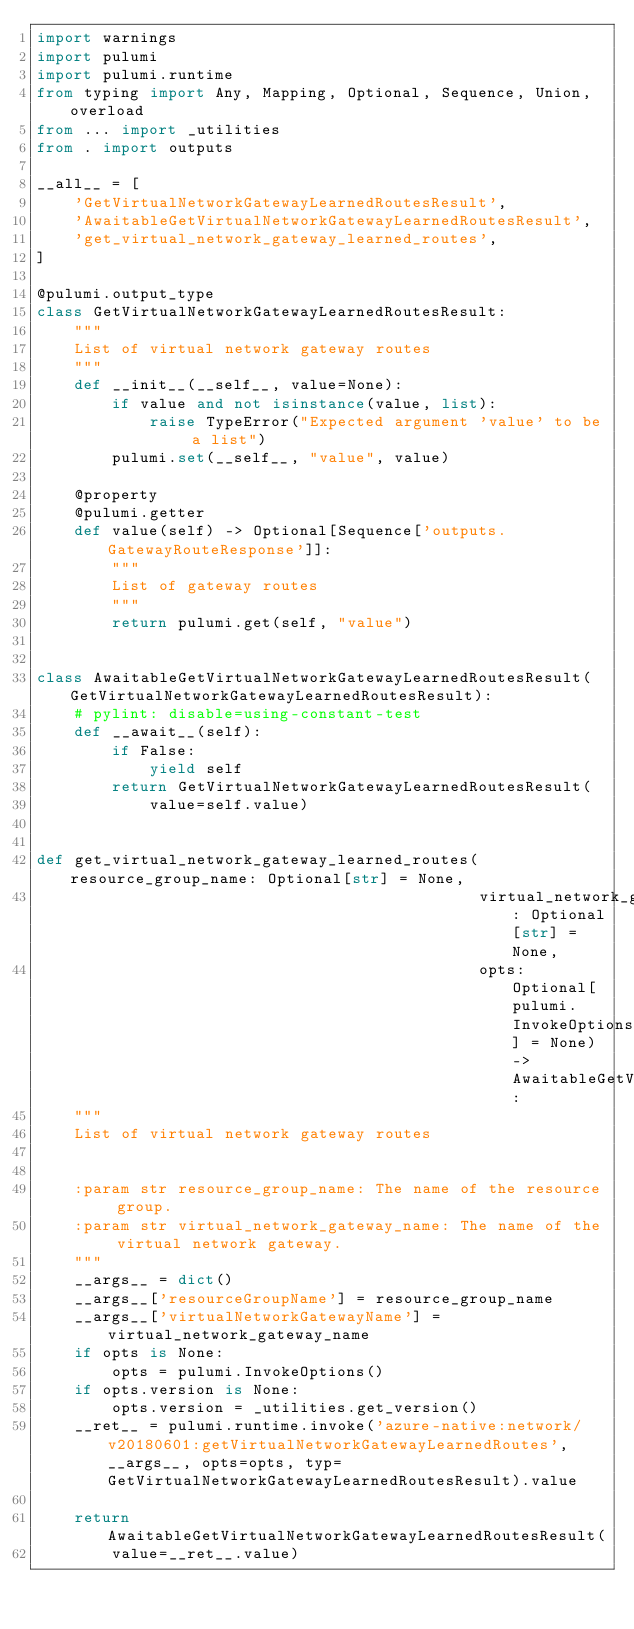Convert code to text. <code><loc_0><loc_0><loc_500><loc_500><_Python_>import warnings
import pulumi
import pulumi.runtime
from typing import Any, Mapping, Optional, Sequence, Union, overload
from ... import _utilities
from . import outputs

__all__ = [
    'GetVirtualNetworkGatewayLearnedRoutesResult',
    'AwaitableGetVirtualNetworkGatewayLearnedRoutesResult',
    'get_virtual_network_gateway_learned_routes',
]

@pulumi.output_type
class GetVirtualNetworkGatewayLearnedRoutesResult:
    """
    List of virtual network gateway routes
    """
    def __init__(__self__, value=None):
        if value and not isinstance(value, list):
            raise TypeError("Expected argument 'value' to be a list")
        pulumi.set(__self__, "value", value)

    @property
    @pulumi.getter
    def value(self) -> Optional[Sequence['outputs.GatewayRouteResponse']]:
        """
        List of gateway routes
        """
        return pulumi.get(self, "value")


class AwaitableGetVirtualNetworkGatewayLearnedRoutesResult(GetVirtualNetworkGatewayLearnedRoutesResult):
    # pylint: disable=using-constant-test
    def __await__(self):
        if False:
            yield self
        return GetVirtualNetworkGatewayLearnedRoutesResult(
            value=self.value)


def get_virtual_network_gateway_learned_routes(resource_group_name: Optional[str] = None,
                                               virtual_network_gateway_name: Optional[str] = None,
                                               opts: Optional[pulumi.InvokeOptions] = None) -> AwaitableGetVirtualNetworkGatewayLearnedRoutesResult:
    """
    List of virtual network gateway routes


    :param str resource_group_name: The name of the resource group.
    :param str virtual_network_gateway_name: The name of the virtual network gateway.
    """
    __args__ = dict()
    __args__['resourceGroupName'] = resource_group_name
    __args__['virtualNetworkGatewayName'] = virtual_network_gateway_name
    if opts is None:
        opts = pulumi.InvokeOptions()
    if opts.version is None:
        opts.version = _utilities.get_version()
    __ret__ = pulumi.runtime.invoke('azure-native:network/v20180601:getVirtualNetworkGatewayLearnedRoutes', __args__, opts=opts, typ=GetVirtualNetworkGatewayLearnedRoutesResult).value

    return AwaitableGetVirtualNetworkGatewayLearnedRoutesResult(
        value=__ret__.value)
</code> 